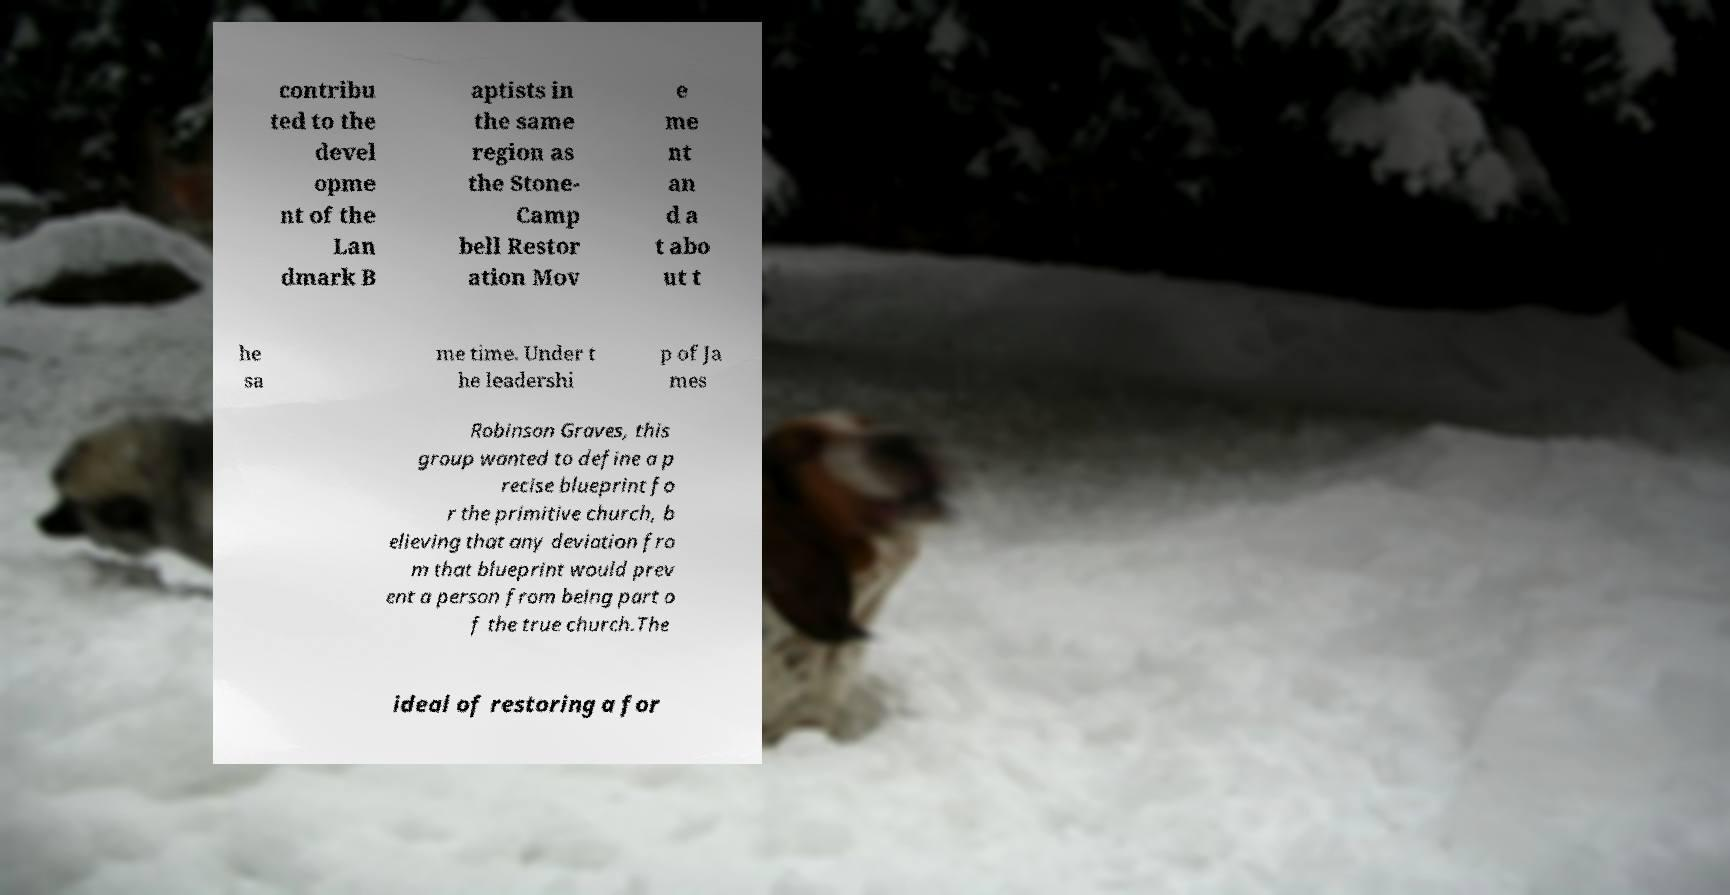Could you assist in decoding the text presented in this image and type it out clearly? contribu ted to the devel opme nt of the Lan dmark B aptists in the same region as the Stone- Camp bell Restor ation Mov e me nt an d a t abo ut t he sa me time. Under t he leadershi p of Ja mes Robinson Graves, this group wanted to define a p recise blueprint fo r the primitive church, b elieving that any deviation fro m that blueprint would prev ent a person from being part o f the true church.The ideal of restoring a for 